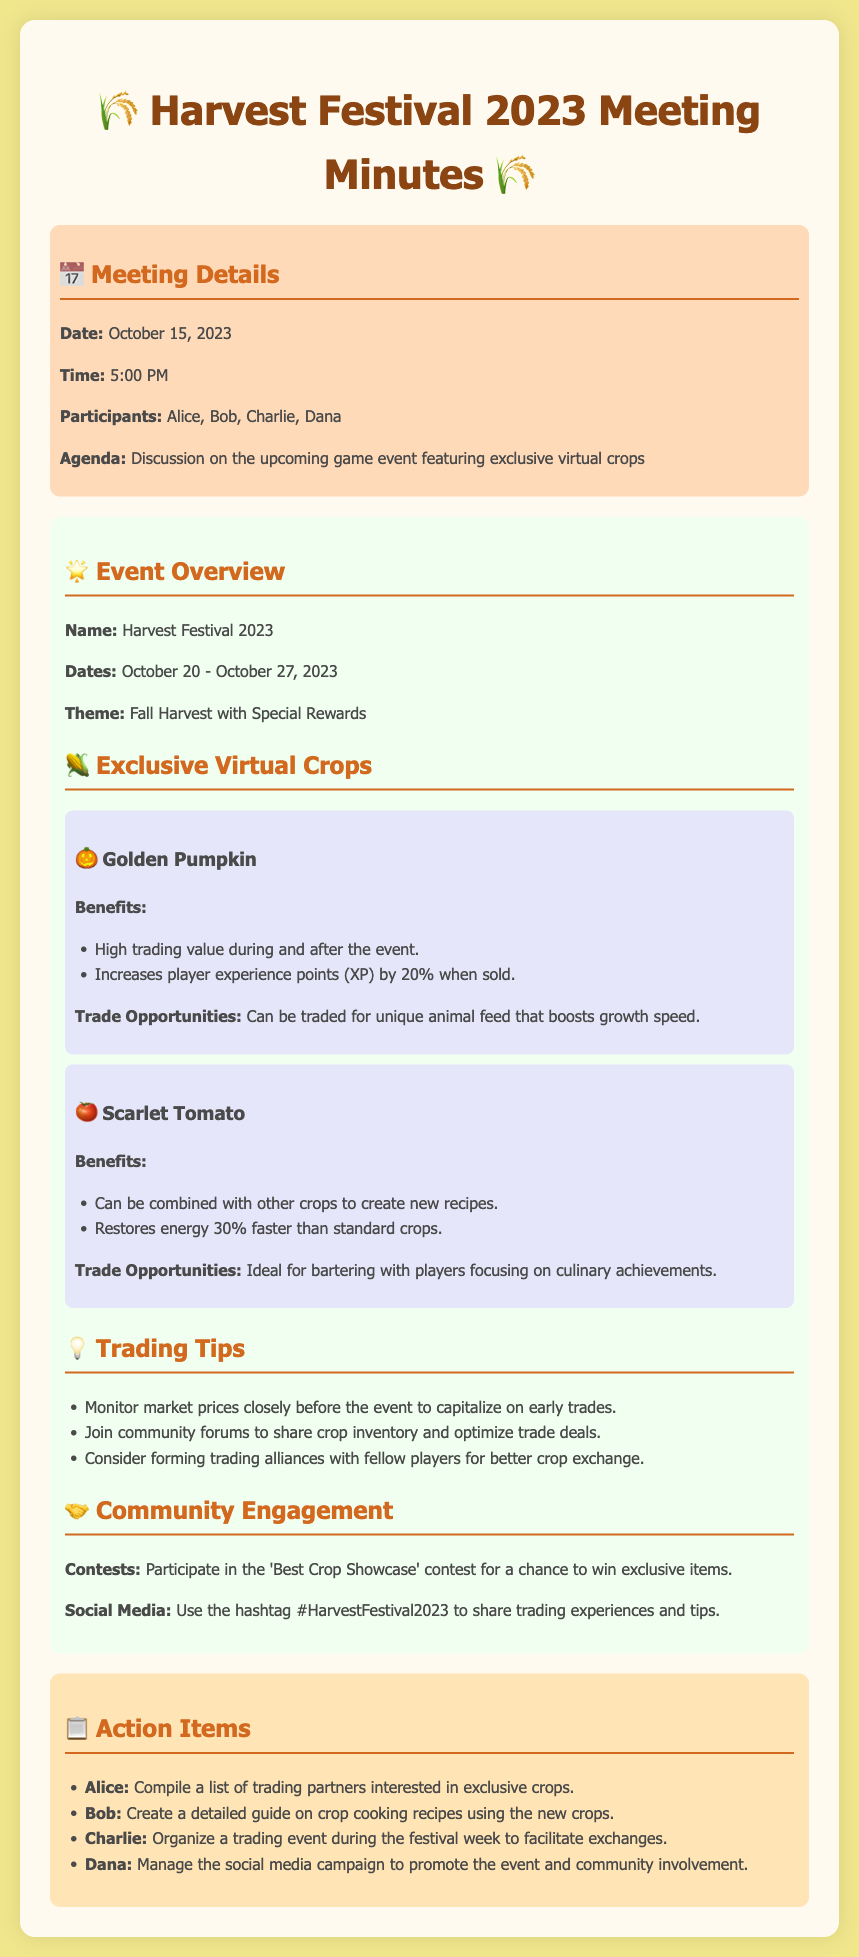What is the event name? The name of the event is stated in the document as "Harvest Festival 2023."
Answer: Harvest Festival 2023 What are the event dates? The document specifies the event dates from October 20 to October 27, 2023.
Answer: October 20 - October 27, 2023 How much does the Golden Pumpkin increase experience points? The document mentions that the Golden Pumpkin increases XP by 20%.
Answer: 20% What crop can be traded for unique animal feed? The document indicates that the Golden Pumpkin can be traded for unique animal feed.
Answer: Golden Pumpkin Which crop restores energy faster? According to the document, the Scarlet Tomato restores energy 30% faster than standard crops.
Answer: Scarlet Tomato Who is tasked with managing the social media campaign? The action item indicates that Dana is responsible for managing the social media campaign.
Answer: Dana What is the theme of the Harvest Festival? The document outlines the theme of the event in the overview section as "Fall Harvest with Special Rewards."
Answer: Fall Harvest with Special Rewards What strategy is suggested for trading? The document suggests monitoring market prices closely as a trading strategy.
Answer: Monitor market prices closely What type of contest is mentioned in community engagement? The document mentions a contest called the 'Best Crop Showcase' in the community engagement section.
Answer: Best Crop Showcase 